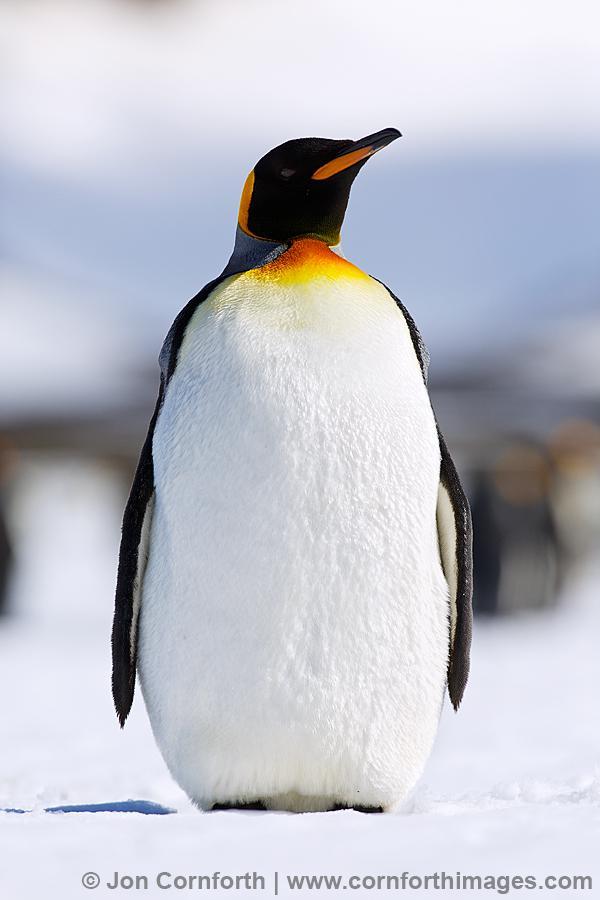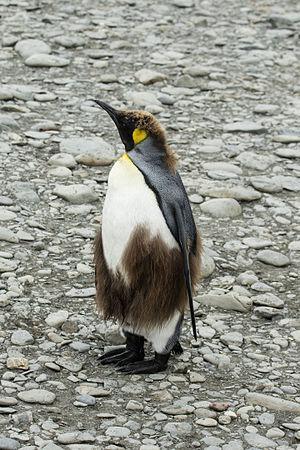The first image is the image on the left, the second image is the image on the right. Considering the images on both sides, is "Both images contain the same number of penguins in the foreground." valid? Answer yes or no. Yes. 